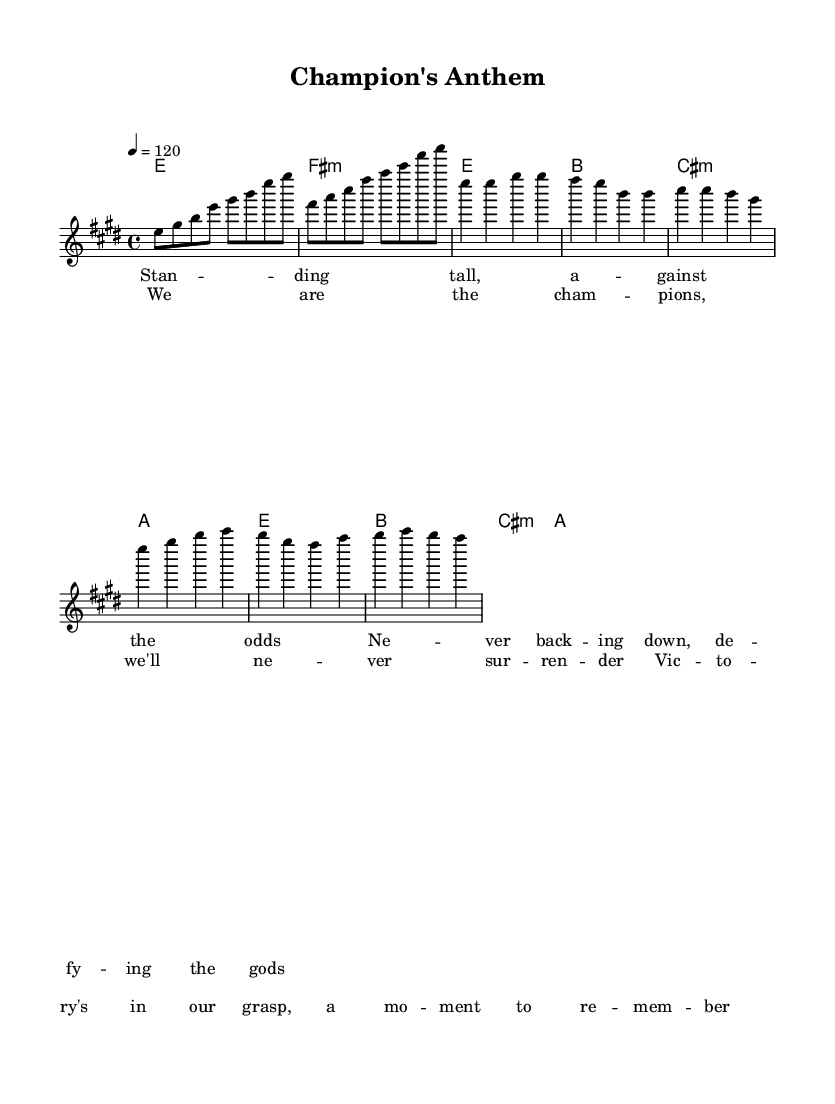What is the key signature of this music? The key signature is E major, which has four sharps (F#, C#, G#, D#). This is indicated at the beginning of the staff where the sharps are placed.
Answer: E major What is the time signature of this music? The time signature is 4/4, which means there are four beats per measure and a quarter note gets one beat. This is displayed at the beginning of the staff, with the numbers indicating the beats and the division of those beats.
Answer: 4/4 What is the tempo marking of the music? The tempo marking is quarter note equals 120. This indicates the speed of the piece, showing that there should be 120 quarter note beats in one minute. It is marked at the beginning of the score.
Answer: 120 How many measures are in the chorus section? The chorus section consists of 4 measures, as can be observed directly from the score where the chorus lyrics align with the staff and the divisions between the measures indicate the total.
Answer: 4 What is the first note of the verse? The first note of the verse is E. This can be determined by looking at the melody line, where it begins with an E note aligned with the lyrics "Standing tall."
Answer: E What chord is played in the first measure? The chord in the first measure is E major. This is identified in the chords section above the melody, showing that E major is played as a whole note in the first measure of both the intro and verse.
Answer: E What type of song is this considered? This song is considered a "Champion's Anthem," as indicated by the title in the header. It reflects themes of victory and perseverance, characteristic of classic rock anthems.
Answer: Champion's Anthem 